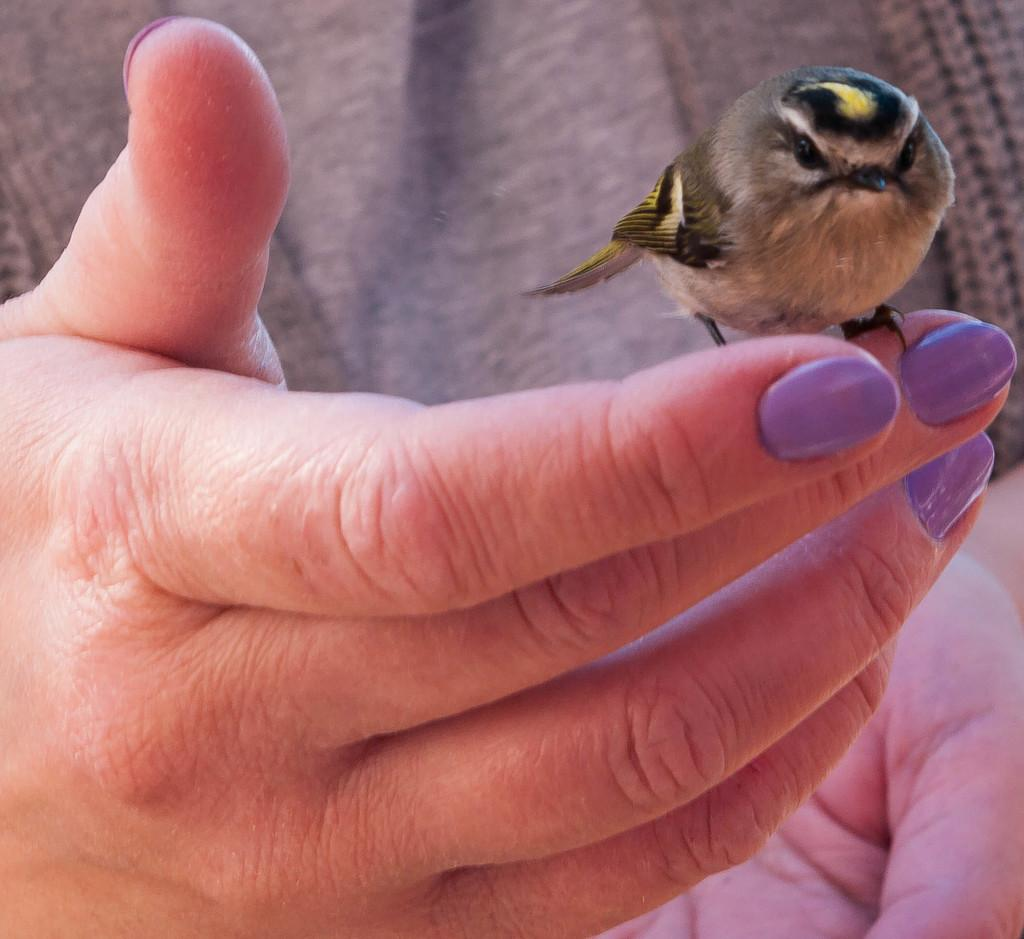What is the main subject of the image? There is a person in the image. What is the person doing in the image? The person is holding a bird. Can you describe the bird in the image? The bird has black, ash, and yellow colors. What type of chess piece is the bird in the image? There is no chess piece present in the image; it features a person holding a bird. 